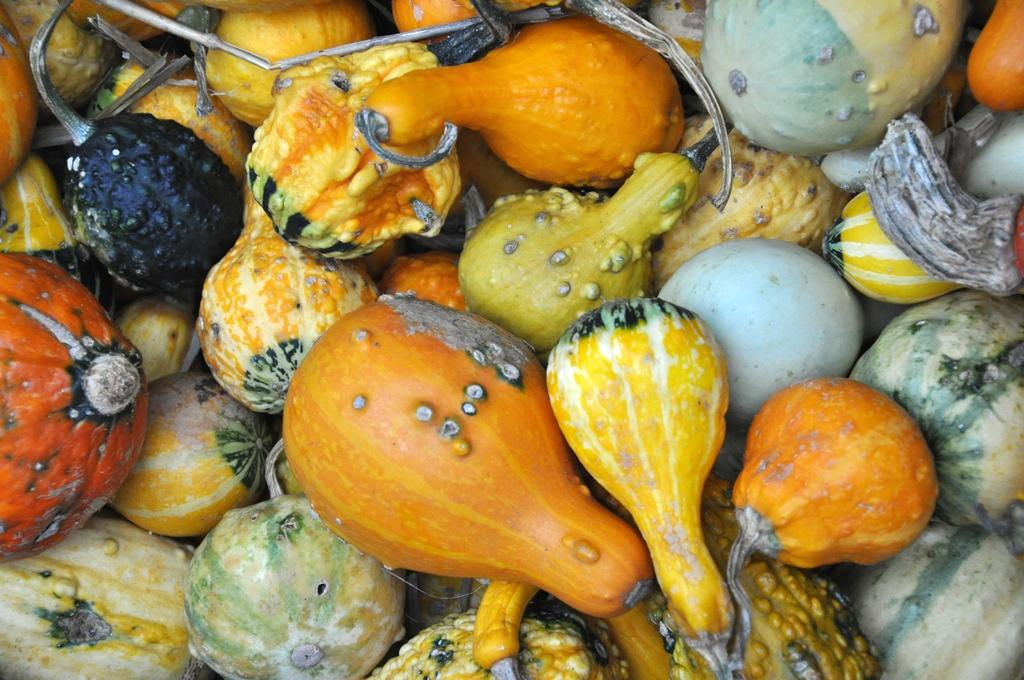What types of food can be seen in the image? There are fruits and vegetables in the image. Can you describe the appearance of the fruits and vegetables? The fruits and vegetables have different colors. What type of brick is being used to build the structure in the middle of the image? There is no brick or structure present in the image; it only features fruits and vegetables. 